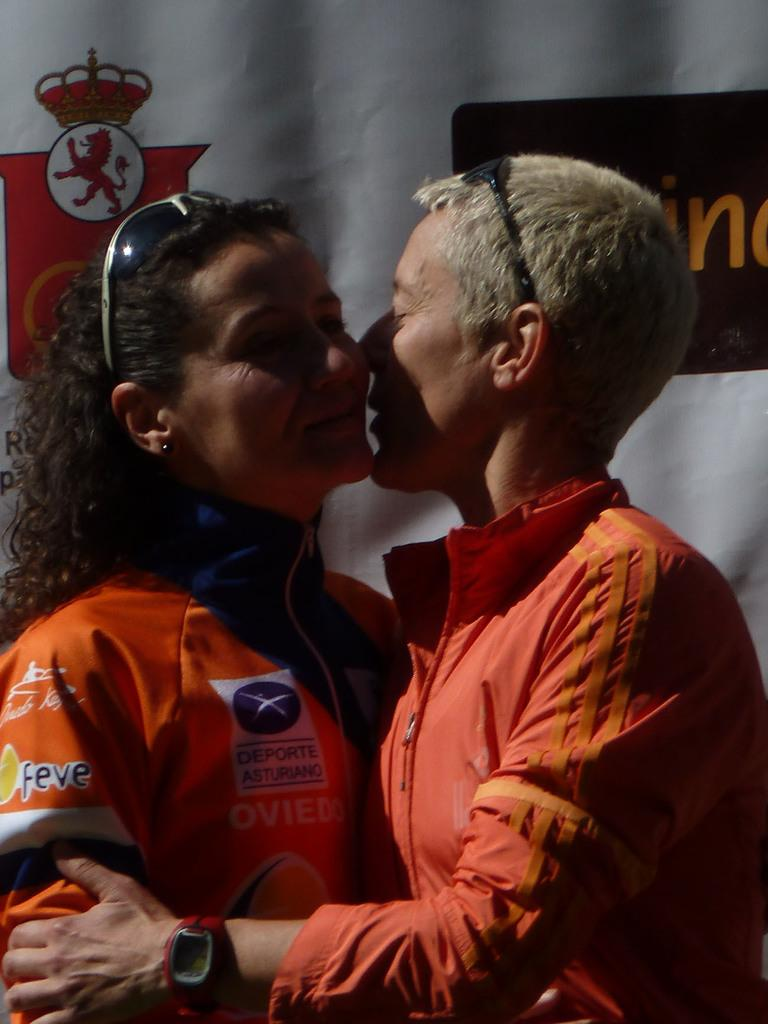What is the woman on the left side of the image wearing? The woman on the left side of the image is wearing an orange T-shirt. What is the woman in the orange T-shirt doing? The woman in the orange T-shirt is hugging another woman. How are the two women in the image interacting? The other woman is also smiling and holding the hand of the woman in the orange T-shirt. What can be seen in the background of the image? There is a banner in the background of the image. How much money is the woman in the orange T-shirt holding in the image? There is no indication of money in the image; the woman in the orange T-shirt is hugging another woman. What type of locket is the woman in the orange T-shirt wearing in the image? There is no locket visible on the woman in the orange T-shirt in the image. 